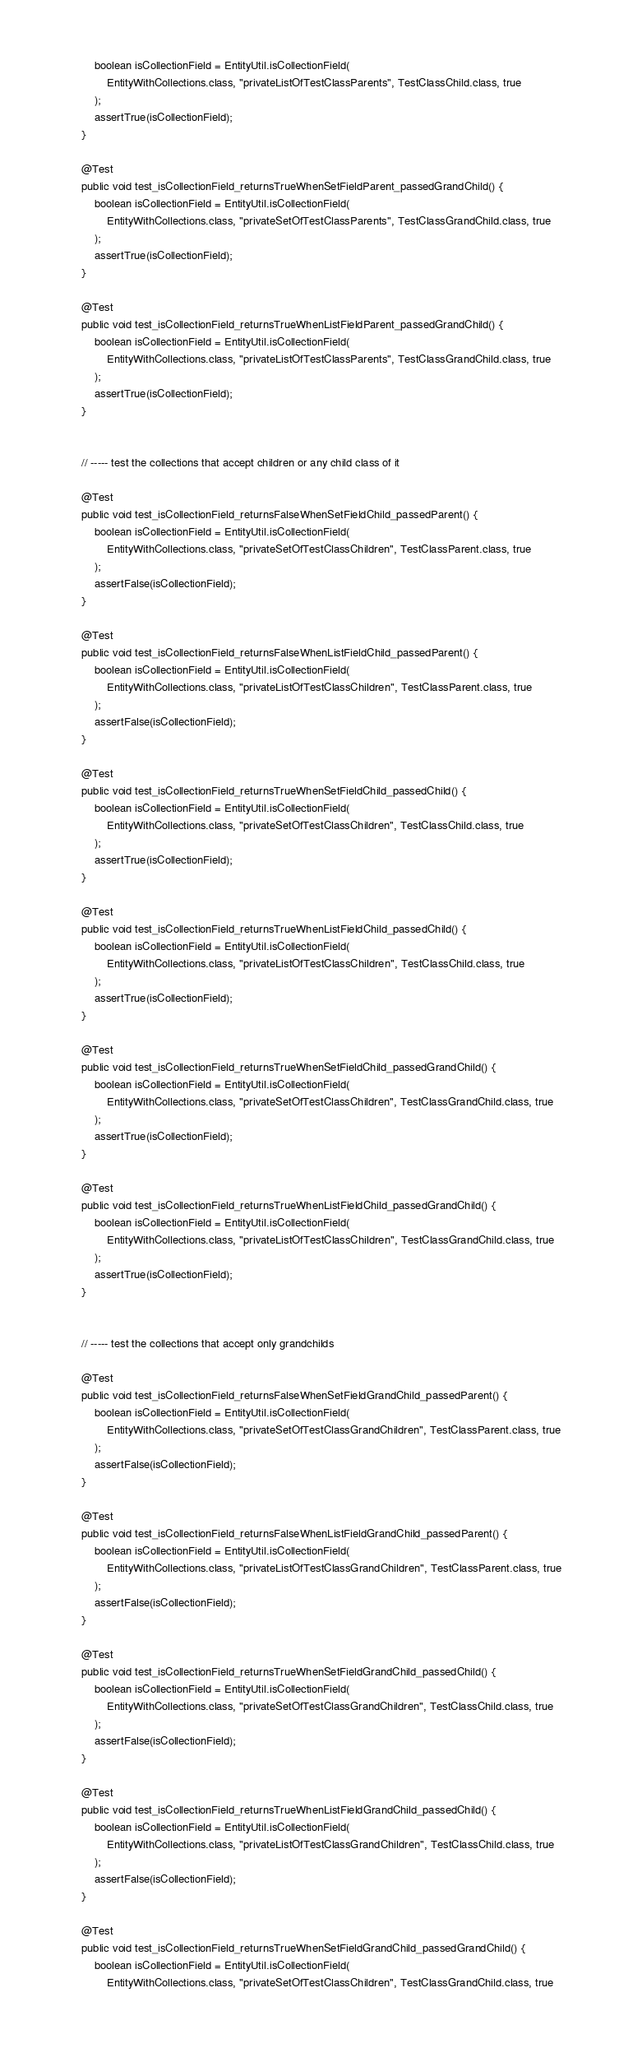Convert code to text. <code><loc_0><loc_0><loc_500><loc_500><_Java_>		boolean isCollectionField = EntityUtil.isCollectionField(
			EntityWithCollections.class, "privateListOfTestClassParents", TestClassChild.class, true
		);
		assertTrue(isCollectionField);
	}

	@Test
	public void test_isCollectionField_returnsTrueWhenSetFieldParent_passedGrandChild() {
		boolean isCollectionField = EntityUtil.isCollectionField(
			EntityWithCollections.class, "privateSetOfTestClassParents", TestClassGrandChild.class, true
		);
		assertTrue(isCollectionField);
	}

	@Test
	public void test_isCollectionField_returnsTrueWhenListFieldParent_passedGrandChild() {
		boolean isCollectionField = EntityUtil.isCollectionField(
			EntityWithCollections.class, "privateListOfTestClassParents", TestClassGrandChild.class, true
		);
		assertTrue(isCollectionField);
	}


	// ----- test the collections that accept children or any child class of it

	@Test
	public void test_isCollectionField_returnsFalseWhenSetFieldChild_passedParent() {
		boolean isCollectionField = EntityUtil.isCollectionField(
			EntityWithCollections.class, "privateSetOfTestClassChildren", TestClassParent.class, true
		);
		assertFalse(isCollectionField);
	}

	@Test
	public void test_isCollectionField_returnsFalseWhenListFieldChild_passedParent() {
		boolean isCollectionField = EntityUtil.isCollectionField(
			EntityWithCollections.class, "privateListOfTestClassChildren", TestClassParent.class, true
		);
		assertFalse(isCollectionField);
	}

	@Test
	public void test_isCollectionField_returnsTrueWhenSetFieldChild_passedChild() {
		boolean isCollectionField = EntityUtil.isCollectionField(
			EntityWithCollections.class, "privateSetOfTestClassChildren", TestClassChild.class, true
		);
		assertTrue(isCollectionField);
	}

	@Test
	public void test_isCollectionField_returnsTrueWhenListFieldChild_passedChild() {
		boolean isCollectionField = EntityUtil.isCollectionField(
			EntityWithCollections.class, "privateListOfTestClassChildren", TestClassChild.class, true
		);
		assertTrue(isCollectionField);
	}

	@Test
	public void test_isCollectionField_returnsTrueWhenSetFieldChild_passedGrandChild() {
		boolean isCollectionField = EntityUtil.isCollectionField(
			EntityWithCollections.class, "privateSetOfTestClassChildren", TestClassGrandChild.class, true
		);
		assertTrue(isCollectionField);
	}

	@Test
	public void test_isCollectionField_returnsTrueWhenListFieldChild_passedGrandChild() {
		boolean isCollectionField = EntityUtil.isCollectionField(
			EntityWithCollections.class, "privateListOfTestClassChildren", TestClassGrandChild.class, true
		);
		assertTrue(isCollectionField);
	}


	// ----- test the collections that accept only grandchilds

	@Test
	public void test_isCollectionField_returnsFalseWhenSetFieldGrandChild_passedParent() {
		boolean isCollectionField = EntityUtil.isCollectionField(
			EntityWithCollections.class, "privateSetOfTestClassGrandChildren", TestClassParent.class, true
		);
		assertFalse(isCollectionField);
	}

	@Test
	public void test_isCollectionField_returnsFalseWhenListFieldGrandChild_passedParent() {
		boolean isCollectionField = EntityUtil.isCollectionField(
			EntityWithCollections.class, "privateListOfTestClassGrandChildren", TestClassParent.class, true
		);
		assertFalse(isCollectionField);
	}

	@Test
	public void test_isCollectionField_returnsTrueWhenSetFieldGrandChild_passedChild() {
		boolean isCollectionField = EntityUtil.isCollectionField(
			EntityWithCollections.class, "privateSetOfTestClassGrandChildren", TestClassChild.class, true
		);
		assertFalse(isCollectionField);
	}

	@Test
	public void test_isCollectionField_returnsTrueWhenListFieldGrandChild_passedChild() {
		boolean isCollectionField = EntityUtil.isCollectionField(
			EntityWithCollections.class, "privateListOfTestClassGrandChildren", TestClassChild.class, true
		);
		assertFalse(isCollectionField);
	}

	@Test
	public void test_isCollectionField_returnsTrueWhenSetFieldGrandChild_passedGrandChild() {
		boolean isCollectionField = EntityUtil.isCollectionField(
			EntityWithCollections.class, "privateSetOfTestClassChildren", TestClassGrandChild.class, true</code> 